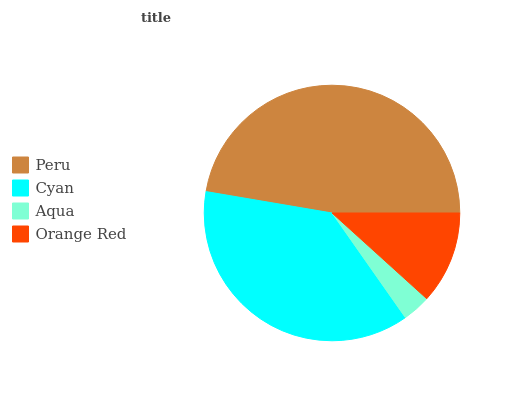Is Aqua the minimum?
Answer yes or no. Yes. Is Peru the maximum?
Answer yes or no. Yes. Is Cyan the minimum?
Answer yes or no. No. Is Cyan the maximum?
Answer yes or no. No. Is Peru greater than Cyan?
Answer yes or no. Yes. Is Cyan less than Peru?
Answer yes or no. Yes. Is Cyan greater than Peru?
Answer yes or no. No. Is Peru less than Cyan?
Answer yes or no. No. Is Cyan the high median?
Answer yes or no. Yes. Is Orange Red the low median?
Answer yes or no. Yes. Is Orange Red the high median?
Answer yes or no. No. Is Cyan the low median?
Answer yes or no. No. 